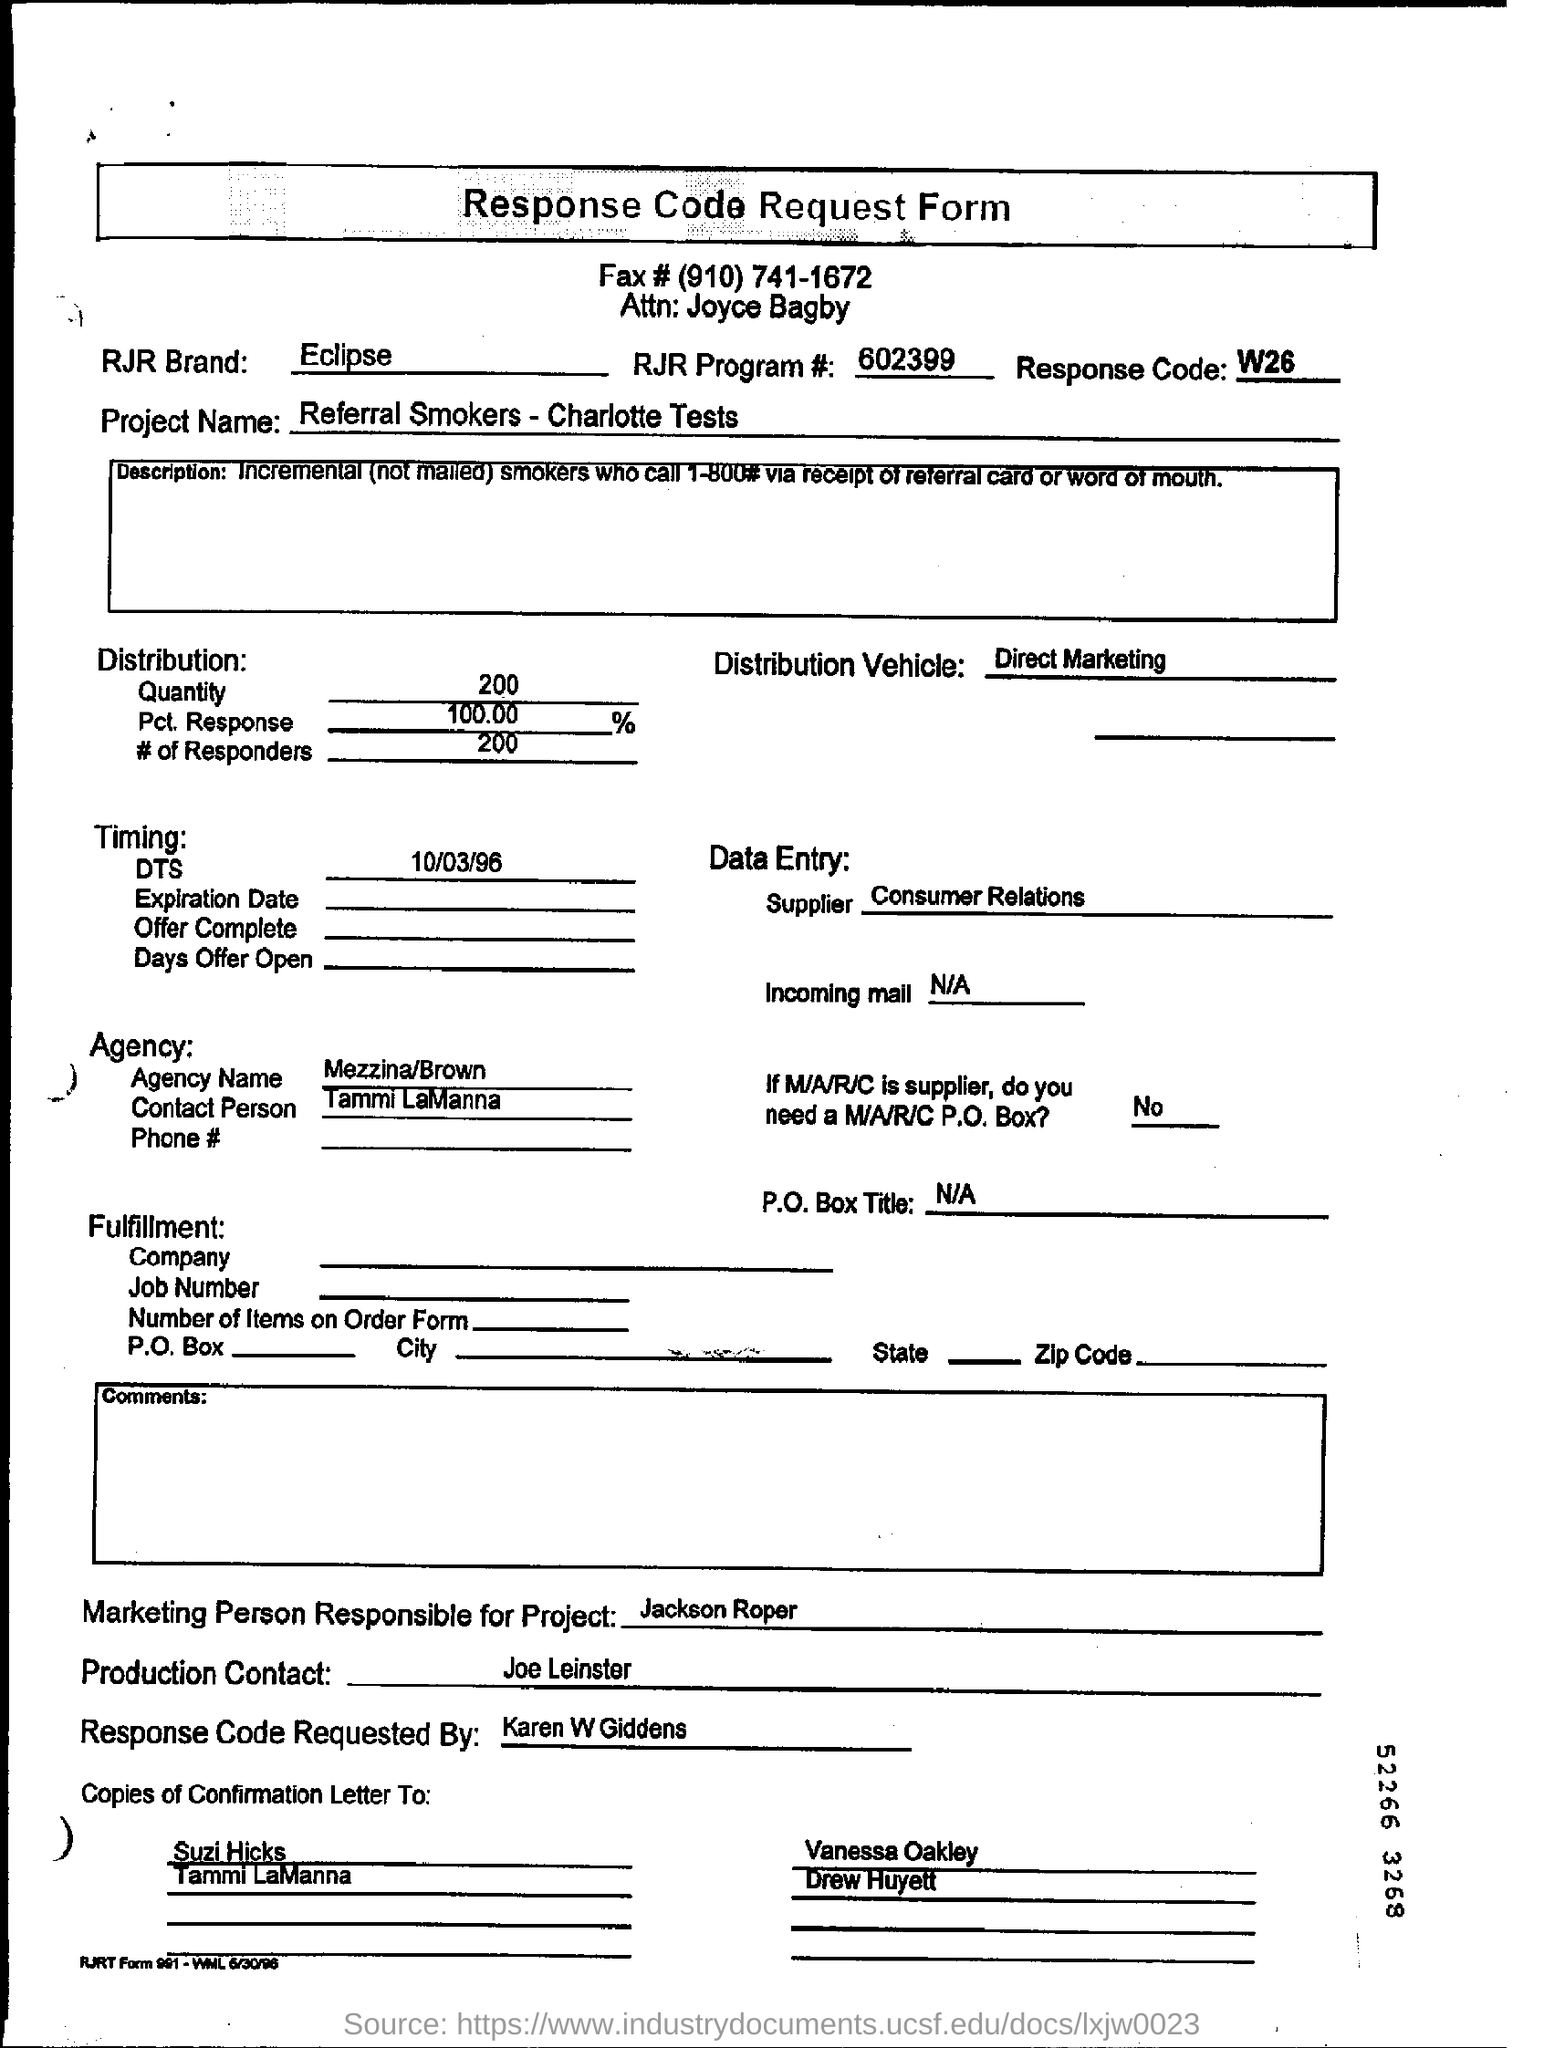Mention a couple of crucial points in this snapshot. The Pct. Response in distribution refers to the percentage of responses that are received from a sample of a population. In other words, it represents the proportion of individuals or items in the population that have responded to a particular survey or questionnaire. For example, if a survey has a sample size of 100 individuals, and 10 of them have responded, the Pct. Response would be 10/100, or 10%. The project name mentioned in the request form is Referral Smokers-Charlotte Tests. The request for the response code was made by Karen W Giddens. This is a declaration that the speaker is filling out a response code request form. The DTS (Date) mentioned in this document is 10/03/96. 